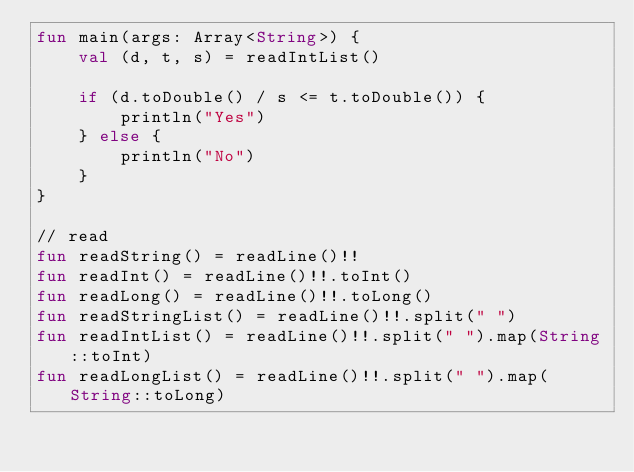Convert code to text. <code><loc_0><loc_0><loc_500><loc_500><_Kotlin_>fun main(args: Array<String>) {
    val (d, t, s) = readIntList()

    if (d.toDouble() / s <= t.toDouble()) {
        println("Yes")
    } else {
        println("No")
    }
}

// read
fun readString() = readLine()!!
fun readInt() = readLine()!!.toInt()
fun readLong() = readLine()!!.toLong()
fun readStringList() = readLine()!!.split(" ")
fun readIntList() = readLine()!!.split(" ").map(String::toInt)
fun readLongList() = readLine()!!.split(" ").map(String::toLong)
</code> 